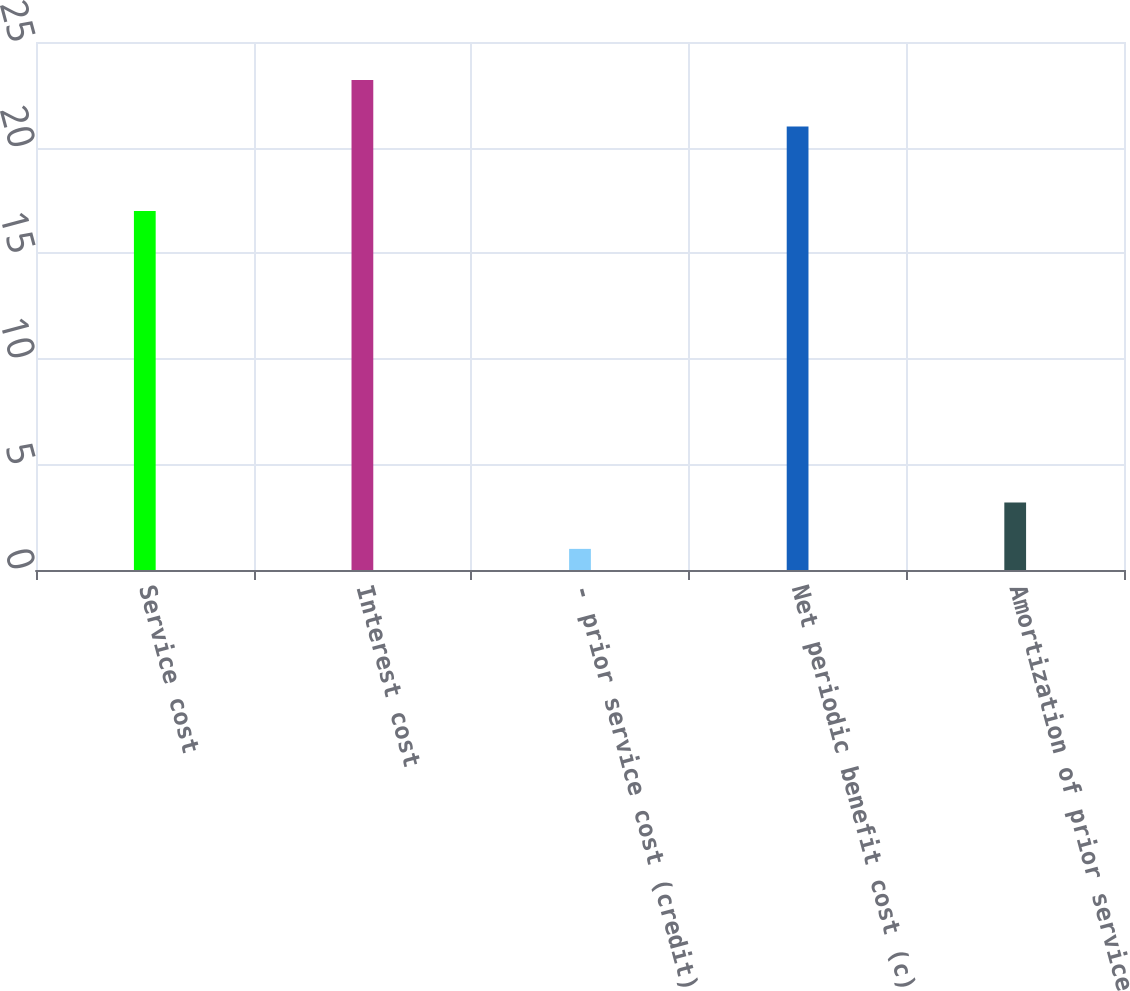Convert chart. <chart><loc_0><loc_0><loc_500><loc_500><bar_chart><fcel>Service cost<fcel>Interest cost<fcel>- prior service cost (credit)<fcel>Net periodic benefit cost (c)<fcel>Amortization of prior service<nl><fcel>17<fcel>23.2<fcel>1<fcel>21<fcel>3.2<nl></chart> 